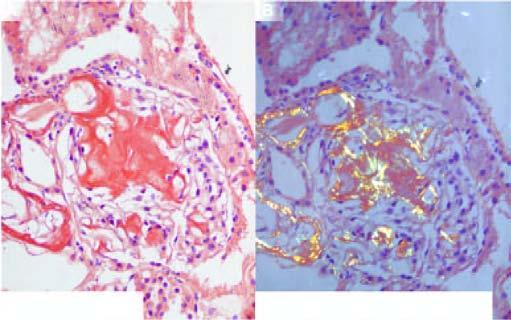do the figure show apple-green birefringence?
Answer the question using a single word or phrase. No 